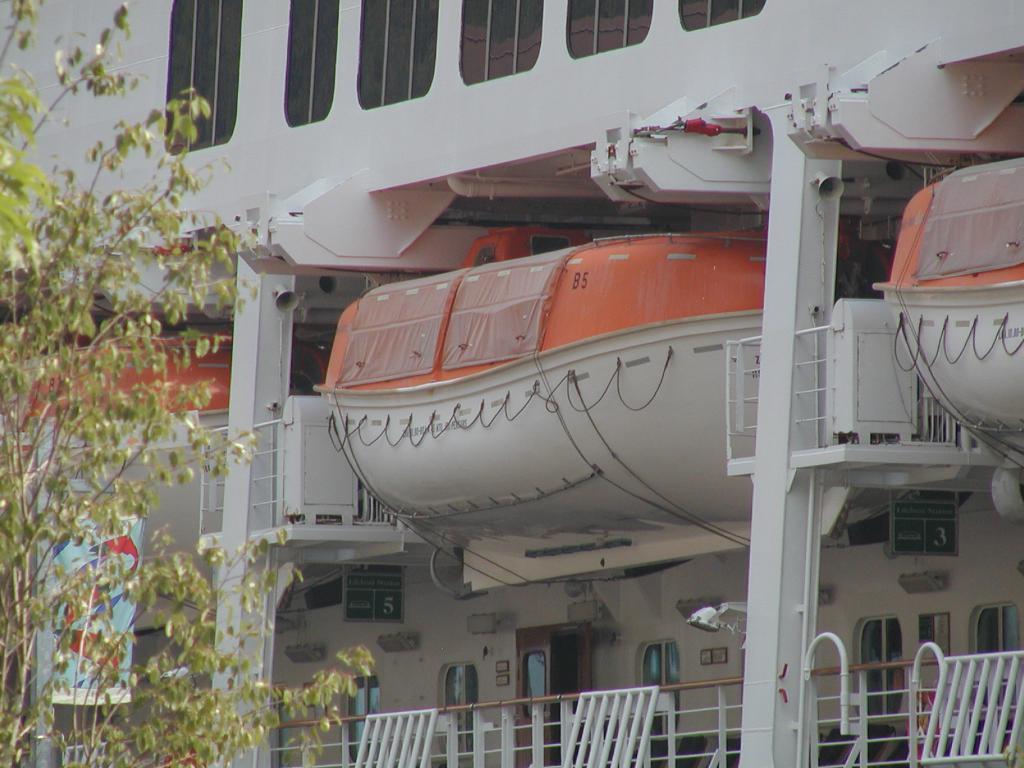In one or two sentences, can you explain what this image depicts? In this image I can see a ship and also there are few lifeboats. At the bottom there is a railing. On the left side there are few trees. 